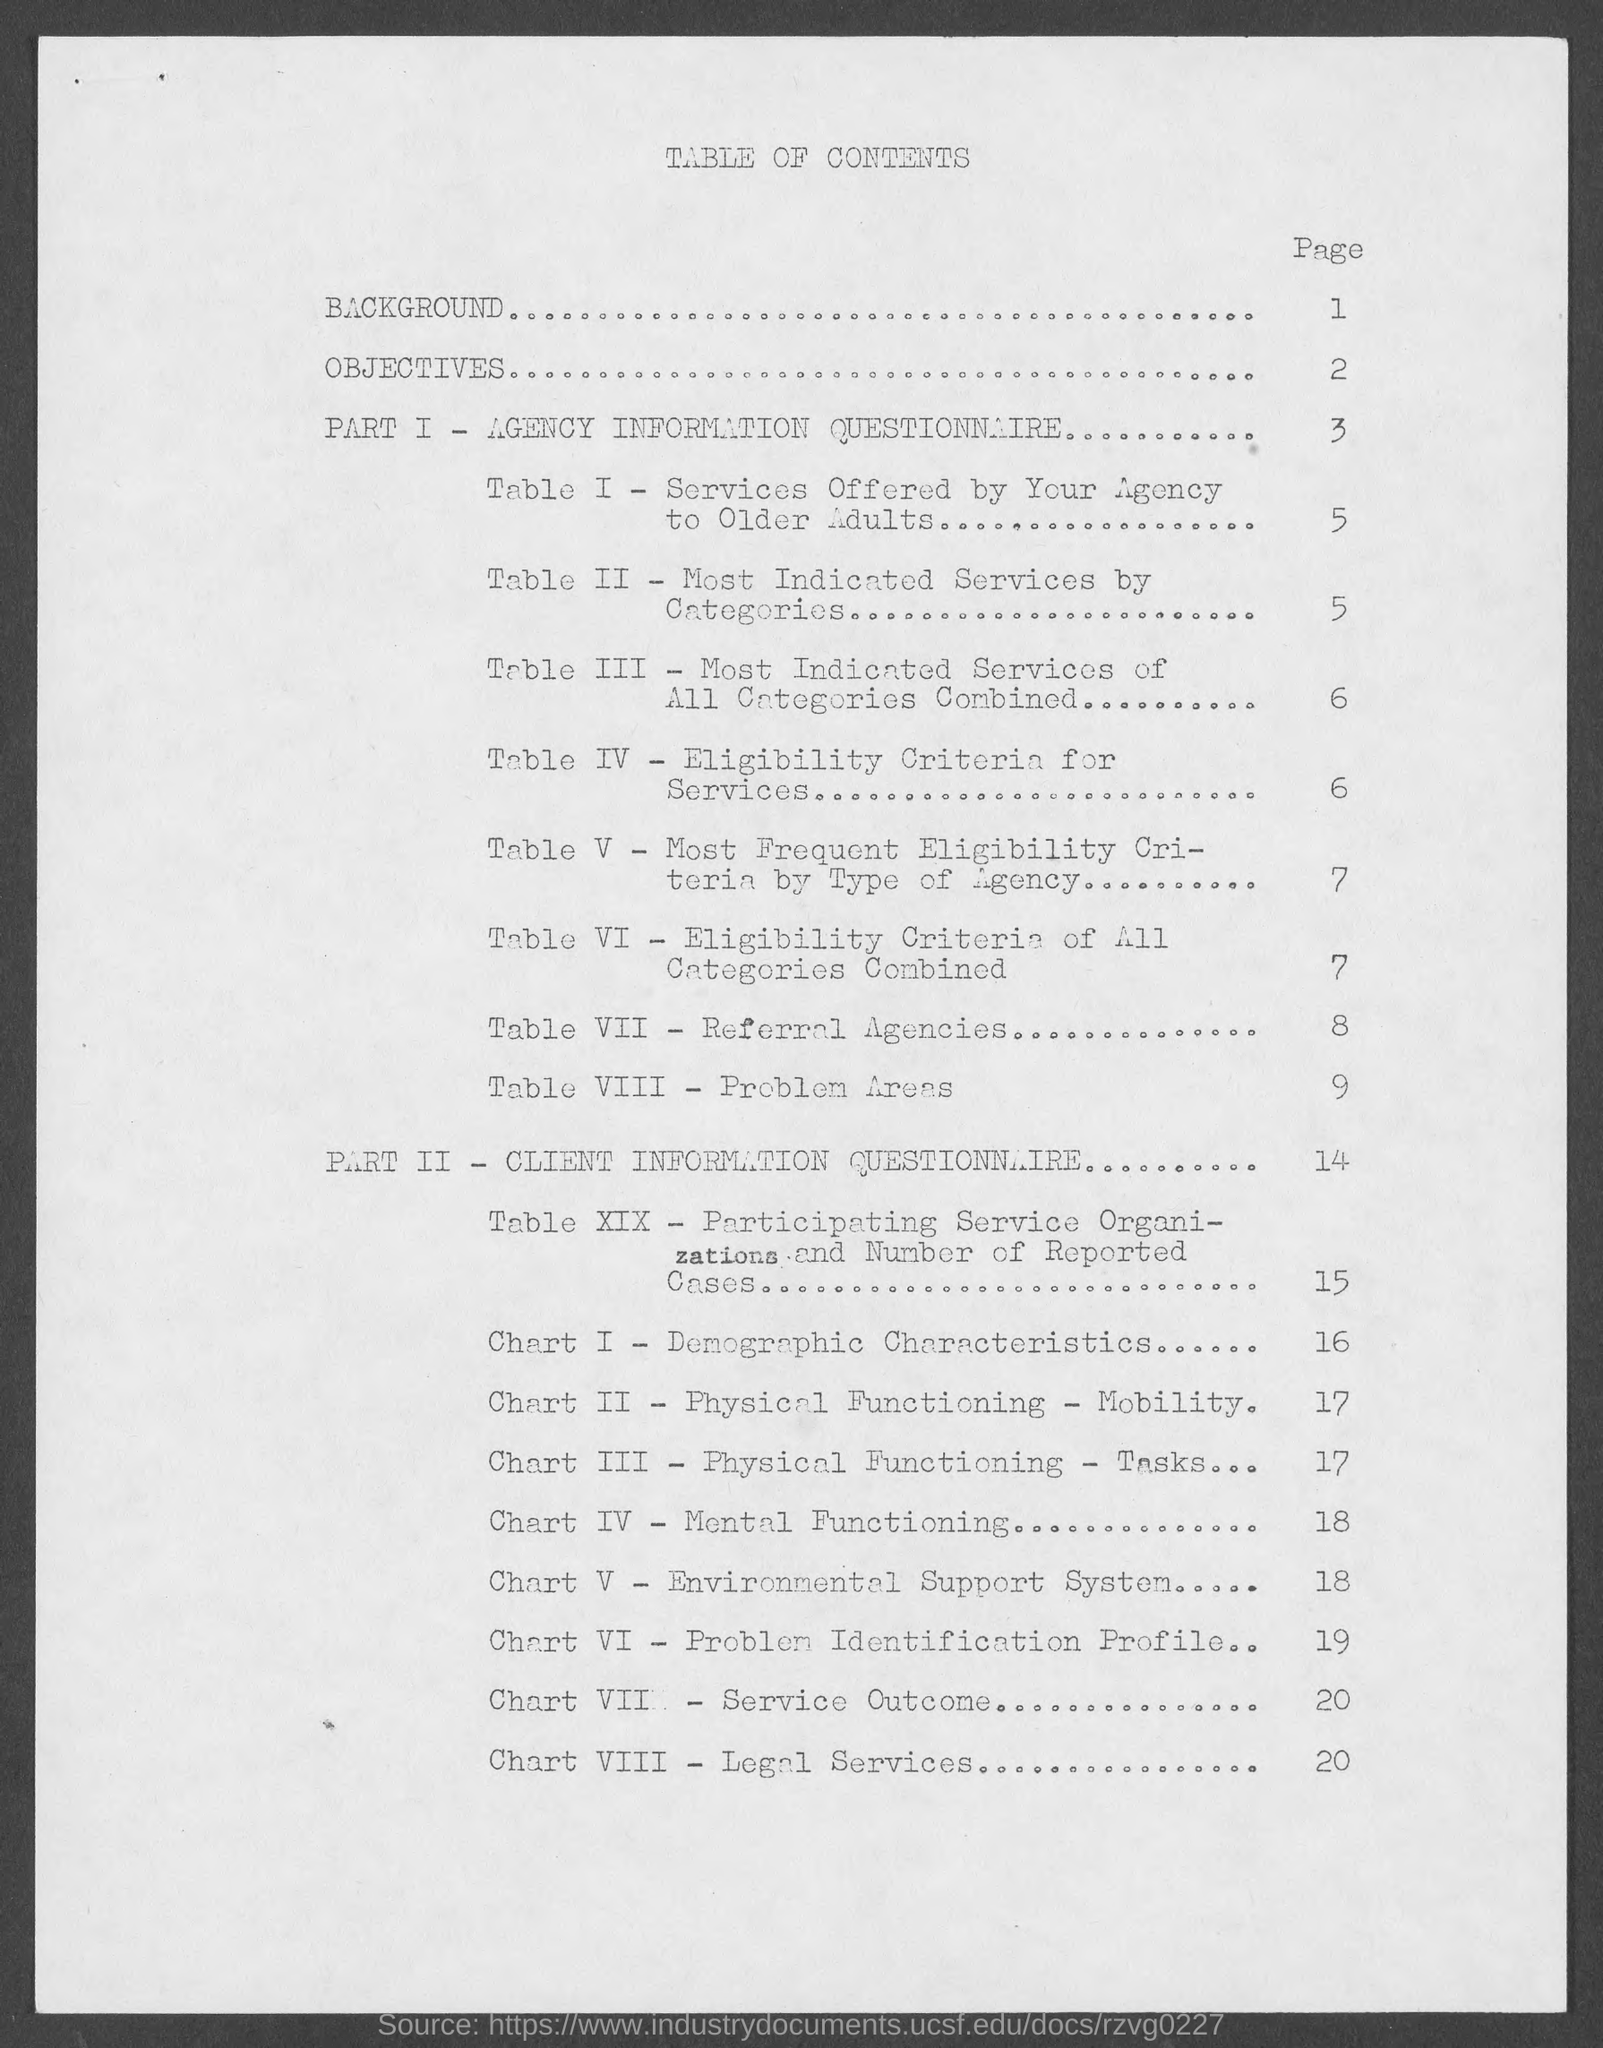What is the Part-1 in this document?
Ensure brevity in your answer.  AGENCY INFORMATION QUESTIONNAIRE. What is the Part-2 in this document?
Provide a short and direct response. CLIENT INFORMATION QUESTIONNAIRE. What is the page number of "Eligibility Criteria for Services" ?
Make the answer very short. 6. 